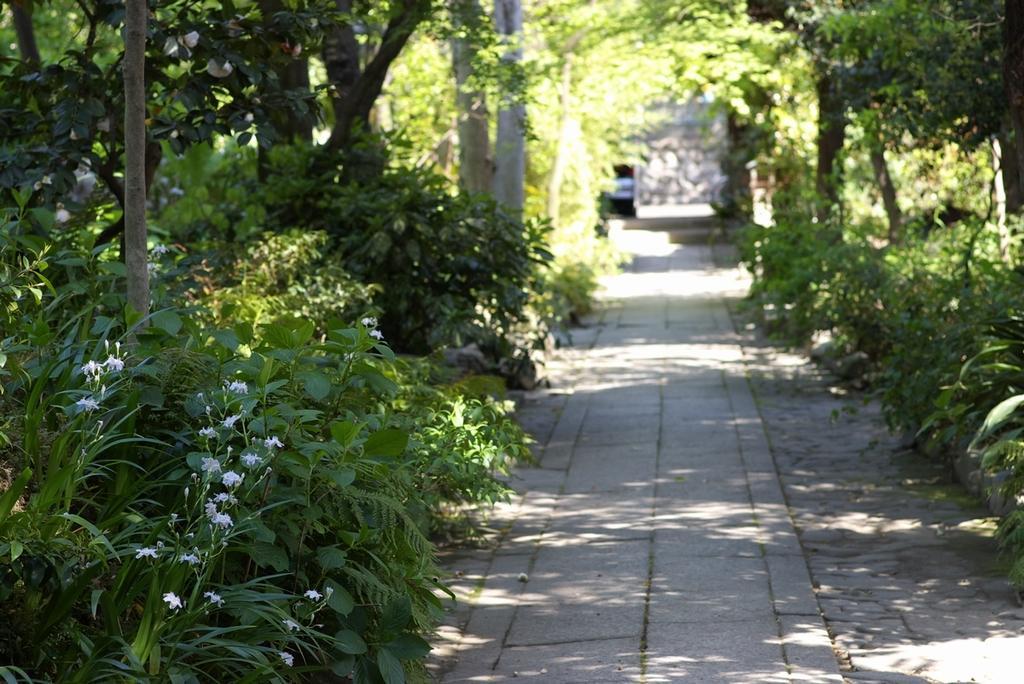Could you give a brief overview of what you see in this image? This image is taken outdoors. At the bottom of the image there is a floor. On the left and right sides of the image there are many trees and plants with green leaves, stems and branches. There are few flowers. 